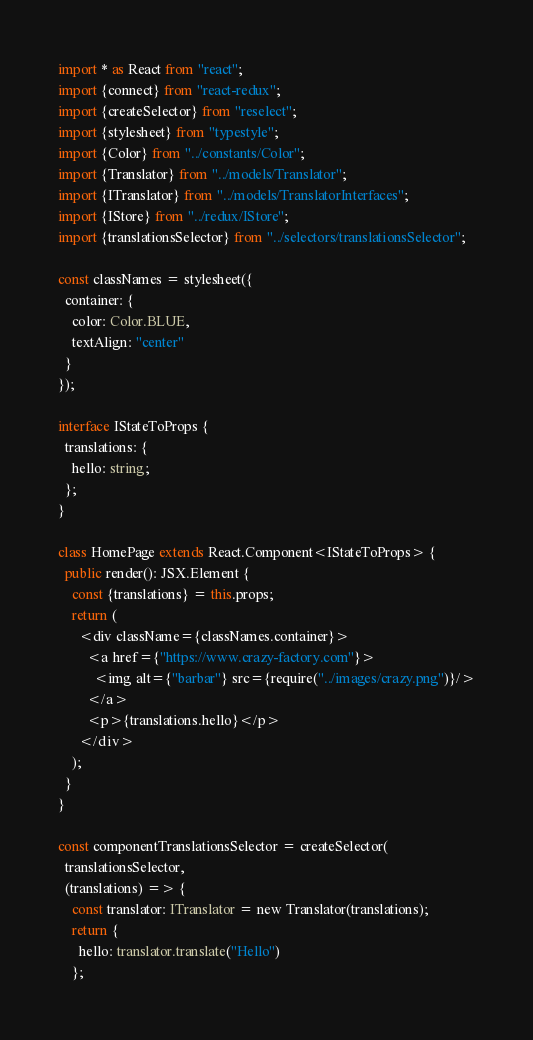<code> <loc_0><loc_0><loc_500><loc_500><_TypeScript_>import * as React from "react";
import {connect} from "react-redux";
import {createSelector} from "reselect";
import {stylesheet} from "typestyle";
import {Color} from "../constants/Color";
import {Translator} from "../models/Translator";
import {ITranslator} from "../models/TranslatorInterfaces";
import {IStore} from "../redux/IStore";
import {translationsSelector} from "../selectors/translationsSelector";

const classNames = stylesheet({
  container: {
    color: Color.BLUE,
    textAlign: "center"
  }
});

interface IStateToProps {
  translations: {
    hello: string;
  };
}

class HomePage extends React.Component<IStateToProps> {
  public render(): JSX.Element {
    const {translations} = this.props;
    return (
      <div className={classNames.container}>
        <a href={"https://www.crazy-factory.com"}>
          <img alt={"barbar"} src={require("../images/crazy.png")}/>
        </a>
        <p>{translations.hello}</p>
      </div>
    );
  }
}

const componentTranslationsSelector = createSelector(
  translationsSelector,
  (translations) => {
    const translator: ITranslator = new Translator(translations);
    return {
      hello: translator.translate("Hello")
    };</code> 